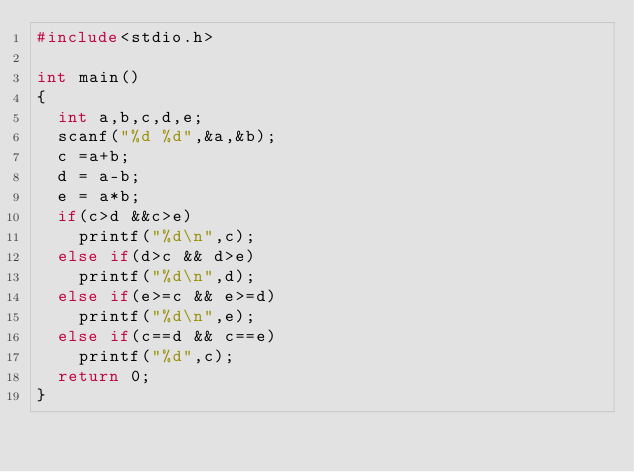<code> <loc_0><loc_0><loc_500><loc_500><_C_>#include<stdio.h>

int main()
{
  int a,b,c,d,e;
  scanf("%d %d",&a,&b);
  c =a+b;
  d = a-b;
  e = a*b;
  if(c>d &&c>e)
    printf("%d\n",c);
  else if(d>c && d>e)
    printf("%d\n",d);
  else if(e>=c && e>=d)
    printf("%d\n",e);
  else if(c==d && c==e)
    printf("%d",c);
  return 0;
}

</code> 